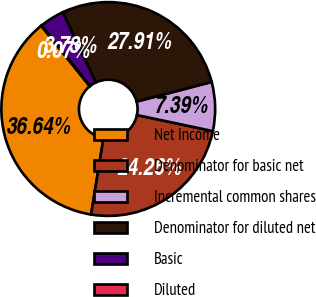<chart> <loc_0><loc_0><loc_500><loc_500><pie_chart><fcel>Net Income<fcel>Denominator for basic net<fcel>Incremental common shares<fcel>Denominator for diluted net<fcel>Basic<fcel>Diluted<nl><fcel>36.64%<fcel>24.26%<fcel>7.39%<fcel>27.91%<fcel>3.73%<fcel>0.07%<nl></chart> 